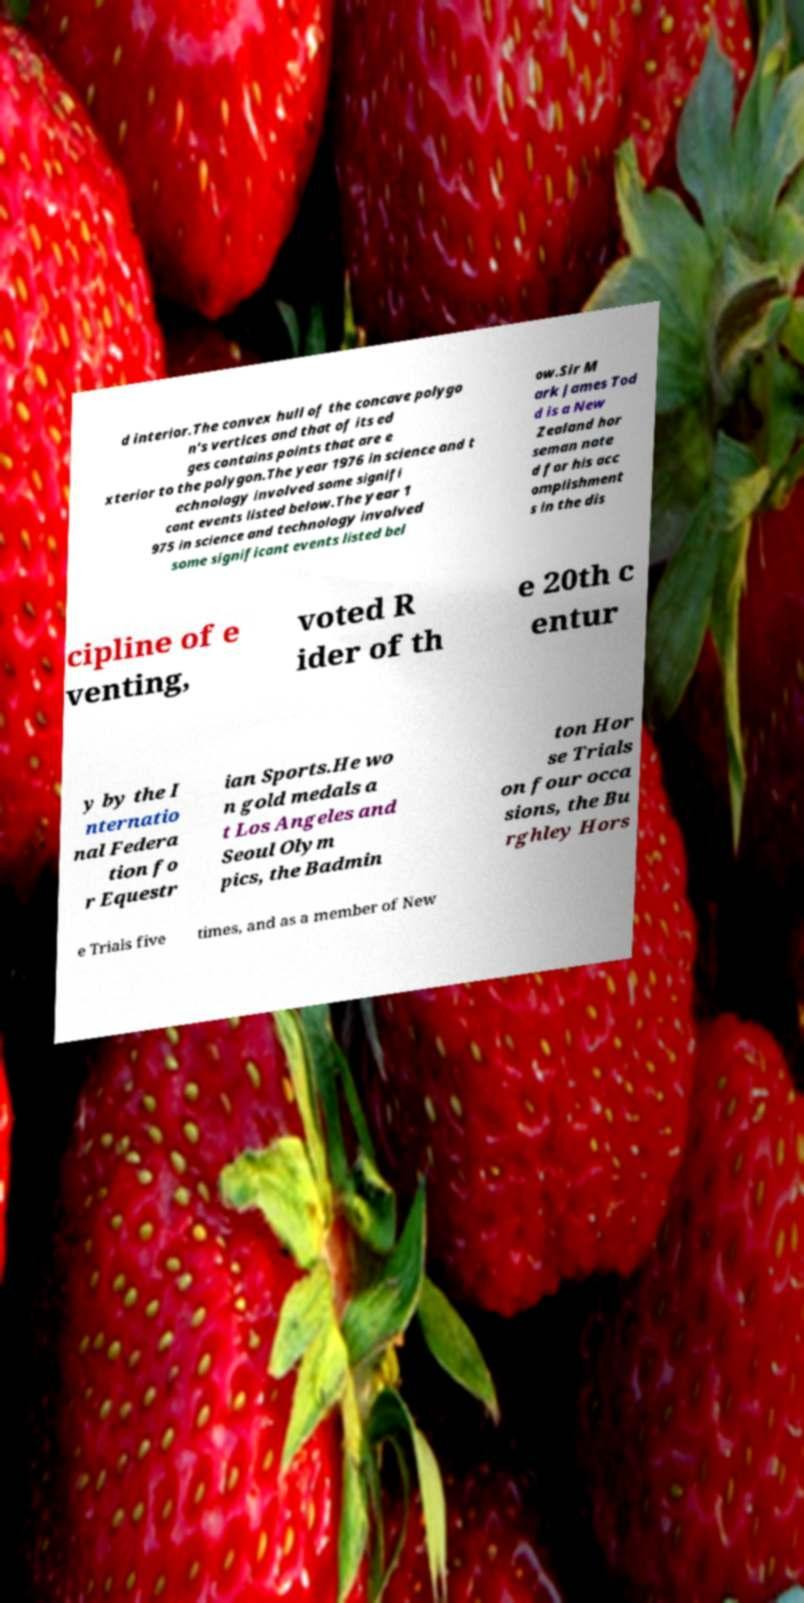Please read and relay the text visible in this image. What does it say? d interior.The convex hull of the concave polygo n's vertices and that of its ed ges contains points that are e xterior to the polygon.The year 1976 in science and t echnology involved some signifi cant events listed below.The year 1 975 in science and technology involved some significant events listed bel ow.Sir M ark James Tod d is a New Zealand hor seman note d for his acc omplishment s in the dis cipline of e venting, voted R ider of th e 20th c entur y by the I nternatio nal Federa tion fo r Equestr ian Sports.He wo n gold medals a t Los Angeles and Seoul Olym pics, the Badmin ton Hor se Trials on four occa sions, the Bu rghley Hors e Trials five times, and as a member of New 